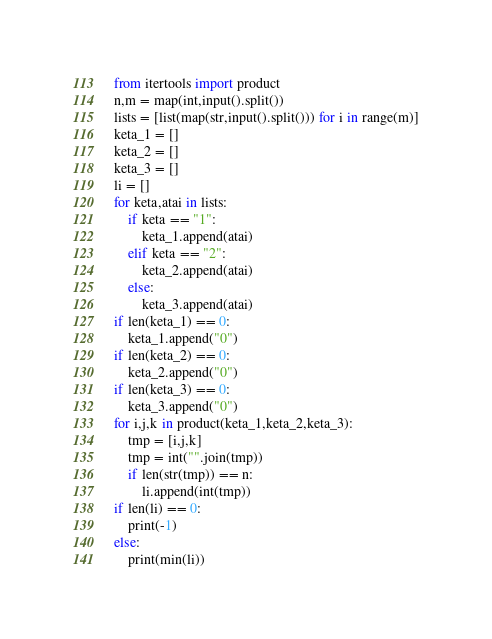Convert code to text. <code><loc_0><loc_0><loc_500><loc_500><_Python_>from itertools import product
n,m = map(int,input().split())
lists = [list(map(str,input().split())) for i in range(m)]
keta_1 = []
keta_2 = []
keta_3 = []
li = []
for keta,atai in lists:
    if keta == "1":
        keta_1.append(atai)
    elif keta == "2":
        keta_2.append(atai)
    else:
        keta_3.append(atai)
if len(keta_1) == 0:
    keta_1.append("0")
if len(keta_2) == 0:
    keta_2.append("0")
if len(keta_3) == 0:
    keta_3.append("0")
for i,j,k in product(keta_1,keta_2,keta_3):
    tmp = [i,j,k]
    tmp = int("".join(tmp))
    if len(str(tmp)) == n:
        li.append(int(tmp))
if len(li) == 0:
    print(-1)
else:
    print(min(li))</code> 